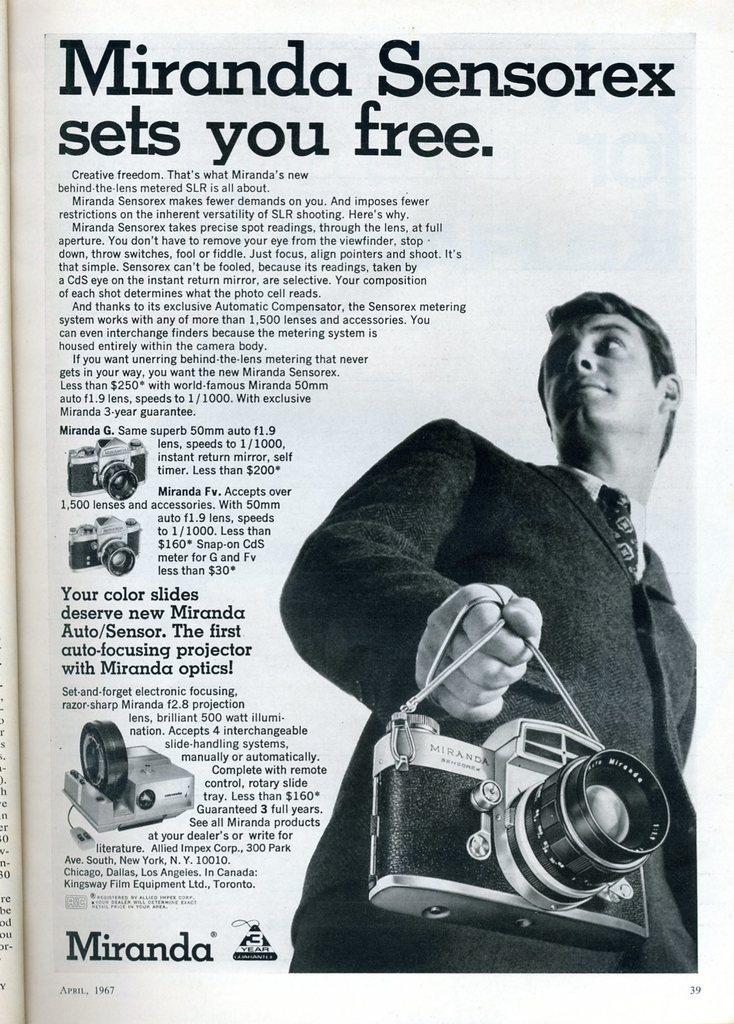How would you summarize this image in a sentence or two? In this image I see a paper on which there is an picture of a man who is holding a camera and I see words and numbers written on it and I see pictures of cameras. 